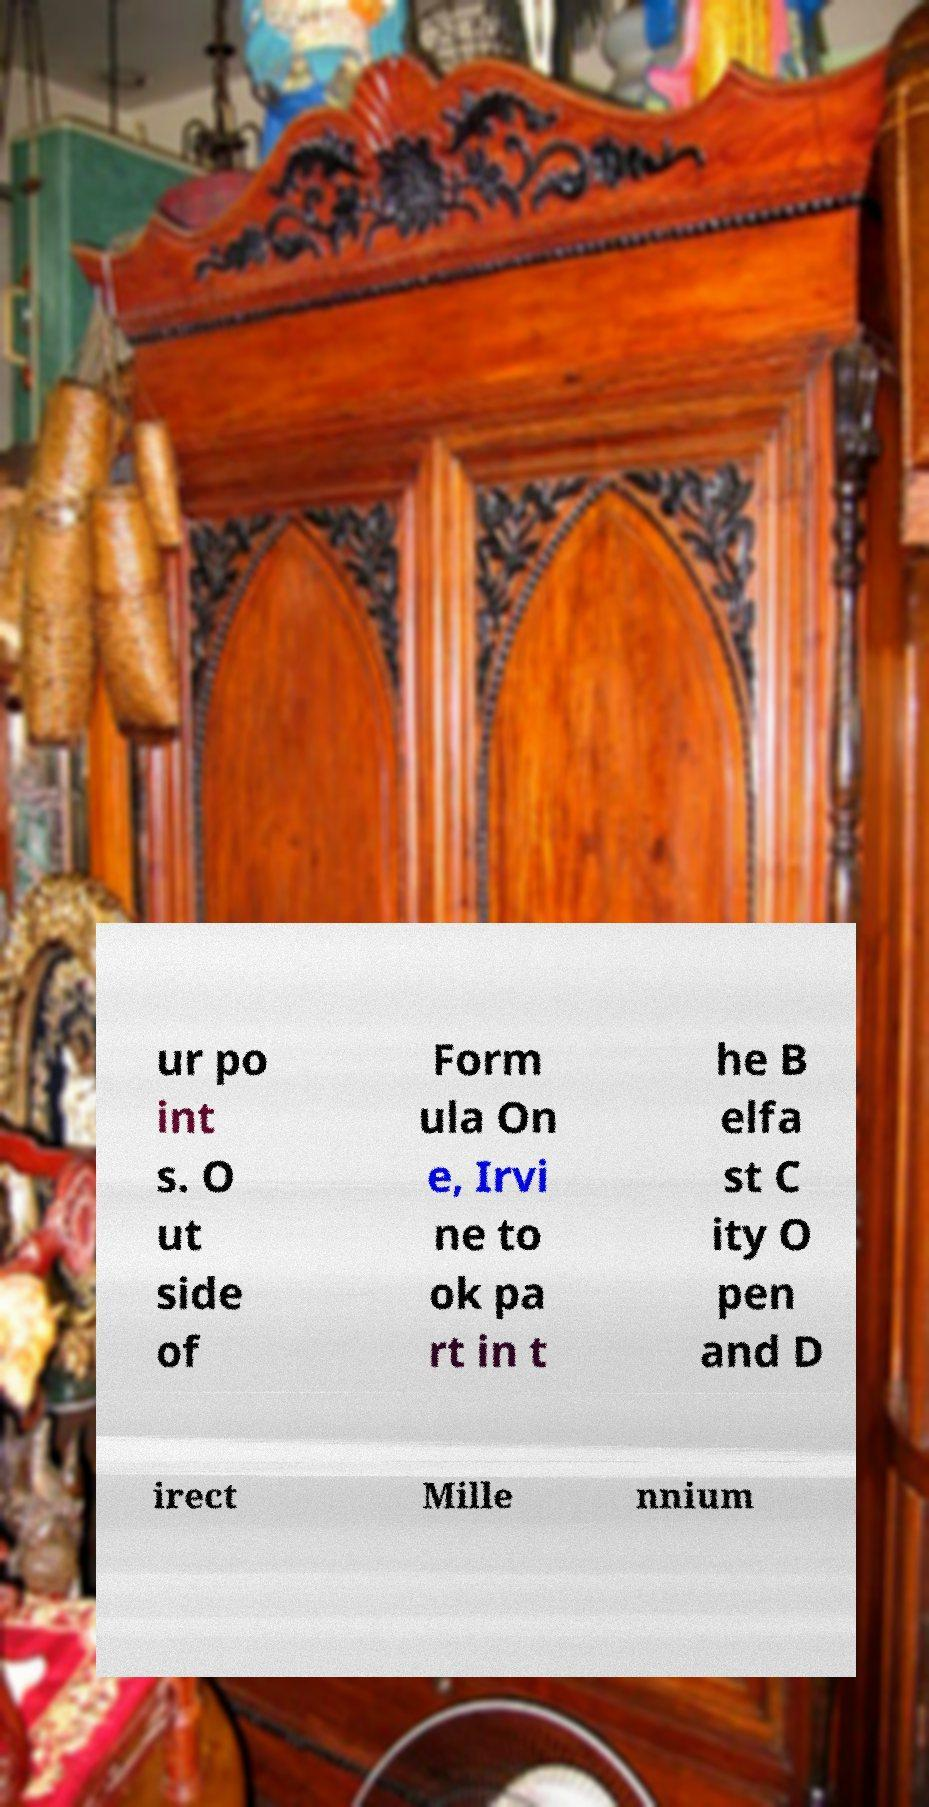I need the written content from this picture converted into text. Can you do that? ur po int s. O ut side of Form ula On e, Irvi ne to ok pa rt in t he B elfa st C ity O pen and D irect Mille nnium 